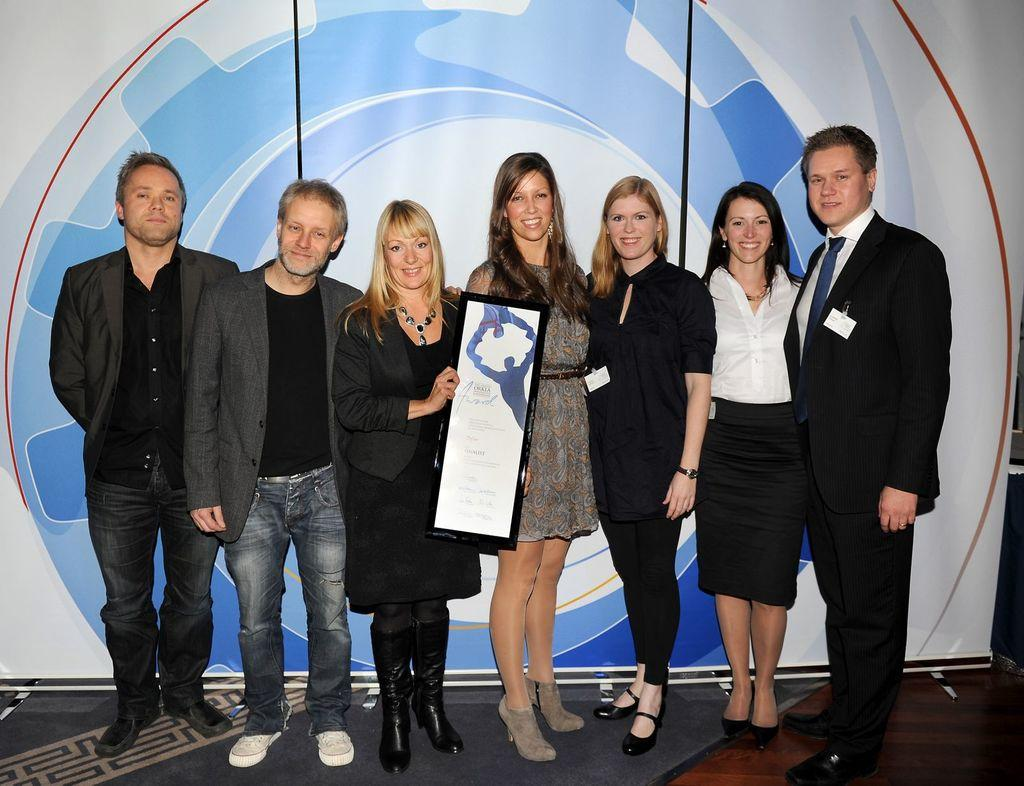How many people are present in the image? There are people in the image, but the exact number cannot be determined from the provided facts. What is the lady holding in the image? There is a lady holding an object in the image. What can be seen on the ground in the image? The ground is visible in the image, but no specific details about the ground are provided. What is depicted on the banner in the background? The banner in the background has an image, but the specific image is not mentioned in the provided facts. What decision did the people make during the party in the image? There is no mention of a party or any decision-making process in the provided facts. 